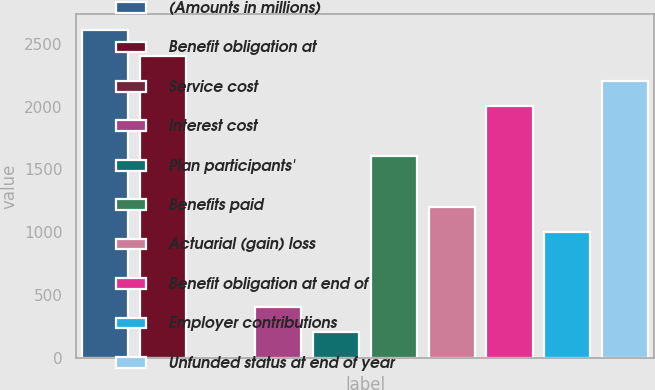<chart> <loc_0><loc_0><loc_500><loc_500><bar_chart><fcel>(Amounts in millions)<fcel>Benefit obligation at<fcel>Service cost<fcel>Interest cost<fcel>Plan participants'<fcel>Benefits paid<fcel>Actuarial (gain) loss<fcel>Benefit obligation at end of<fcel>Employer contributions<fcel>Unfunded status at end of year<nl><fcel>2607.65<fcel>2407.1<fcel>0.5<fcel>401.6<fcel>201.05<fcel>1604.9<fcel>1203.8<fcel>2006<fcel>1003.25<fcel>2206.55<nl></chart> 